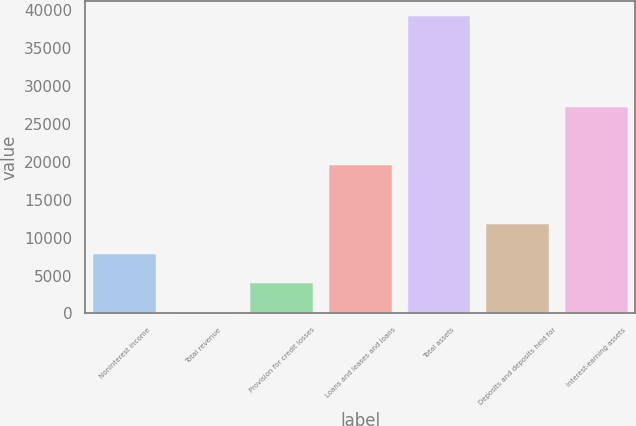Convert chart to OTSL. <chart><loc_0><loc_0><loc_500><loc_500><bar_chart><fcel>Noninterest income<fcel>Total revenue<fcel>Provision for credit losses<fcel>Loans and leases and loans<fcel>Total assets<fcel>Deposits and deposits held for<fcel>Interest-earning assets<nl><fcel>7889.6<fcel>69<fcel>3979.3<fcel>19620.5<fcel>39172<fcel>11799.9<fcel>27243<nl></chart> 